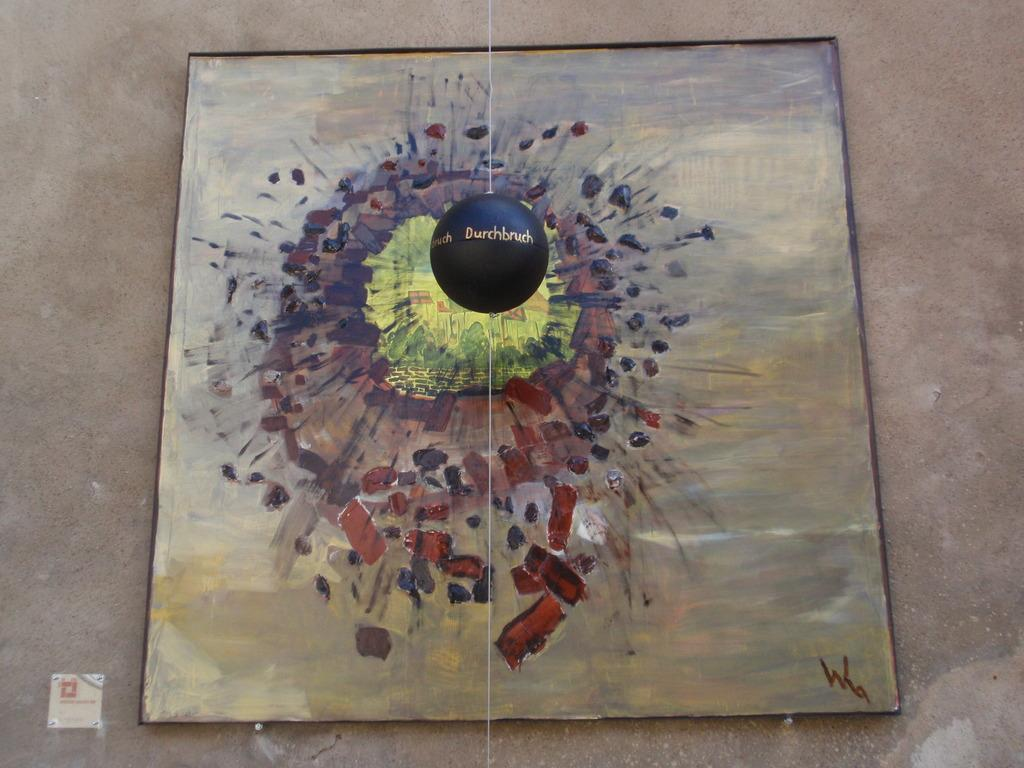What is the main object in the center of the image? There is a black ball in the center of the image. Is there anything attached to the black ball? Yes, a thread is tied to the black ball. What can be seen in the background of the image? There is a wall and a painting board in the background of the image. What type of unit is being measured with the celery in the image? There is no celery or measurement unit present in the image. What season is depicted in the image? The image does not depict a specific season; it only shows a black ball with a thread, a wall, and a painting board in the background. 